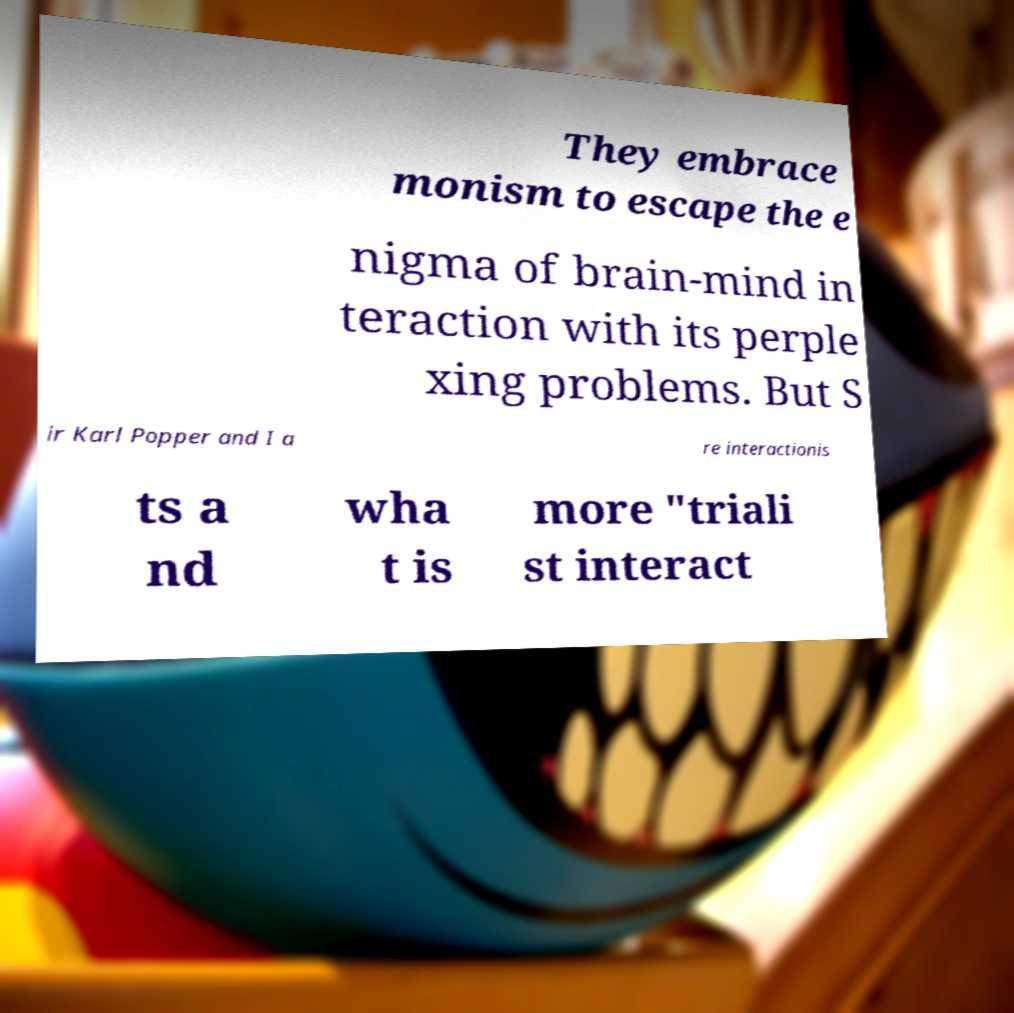There's text embedded in this image that I need extracted. Can you transcribe it verbatim? They embrace monism to escape the e nigma of brain-mind in teraction with its perple xing problems. But S ir Karl Popper and I a re interactionis ts a nd wha t is more "triali st interact 